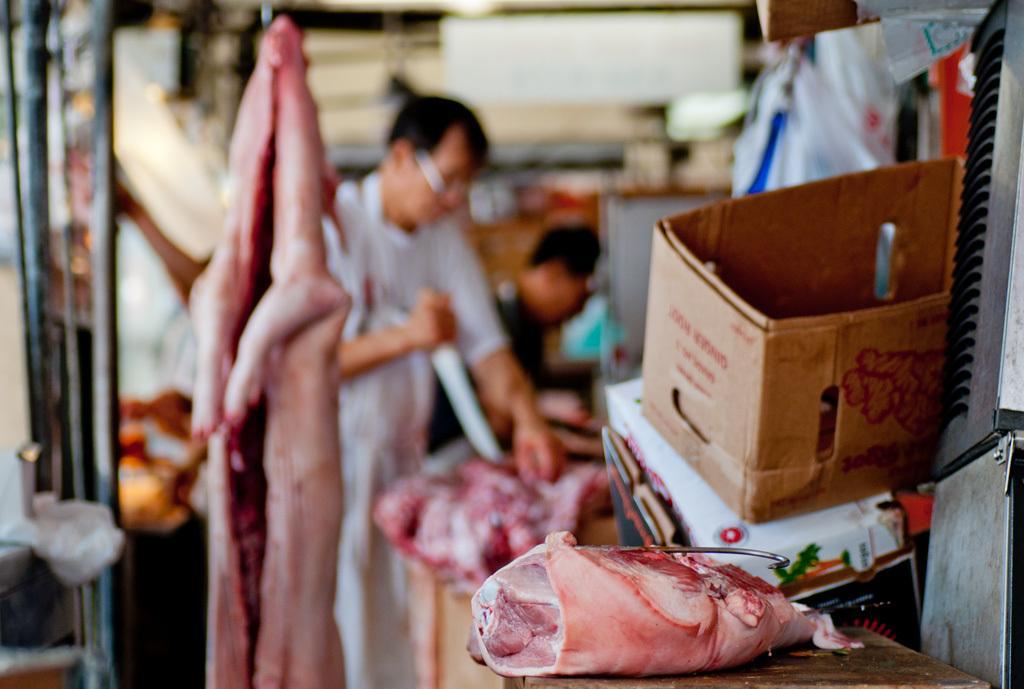Describe this image in one or two sentences. In this image there is a meat and we can see a cardboard box. In the background there are people and we can see some objects. At the bottom there is a table. 